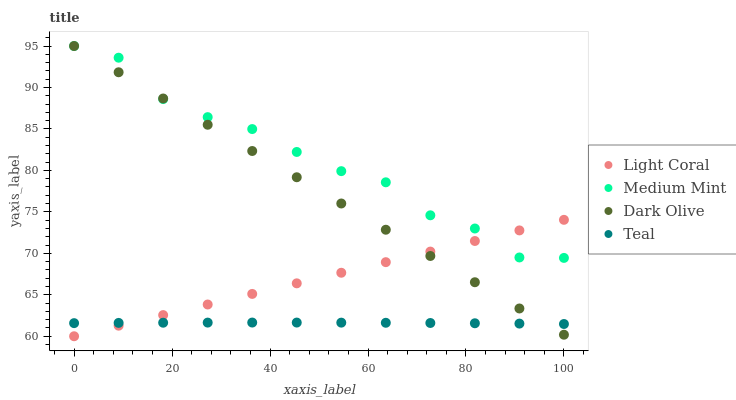Does Teal have the minimum area under the curve?
Answer yes or no. Yes. Does Medium Mint have the maximum area under the curve?
Answer yes or no. Yes. Does Dark Olive have the minimum area under the curve?
Answer yes or no. No. Does Dark Olive have the maximum area under the curve?
Answer yes or no. No. Is Dark Olive the smoothest?
Answer yes or no. Yes. Is Medium Mint the roughest?
Answer yes or no. Yes. Is Medium Mint the smoothest?
Answer yes or no. No. Is Dark Olive the roughest?
Answer yes or no. No. Does Light Coral have the lowest value?
Answer yes or no. Yes. Does Dark Olive have the lowest value?
Answer yes or no. No. Does Dark Olive have the highest value?
Answer yes or no. Yes. Does Teal have the highest value?
Answer yes or no. No. Is Teal less than Medium Mint?
Answer yes or no. Yes. Is Medium Mint greater than Teal?
Answer yes or no. Yes. Does Dark Olive intersect Teal?
Answer yes or no. Yes. Is Dark Olive less than Teal?
Answer yes or no. No. Is Dark Olive greater than Teal?
Answer yes or no. No. Does Teal intersect Medium Mint?
Answer yes or no. No. 